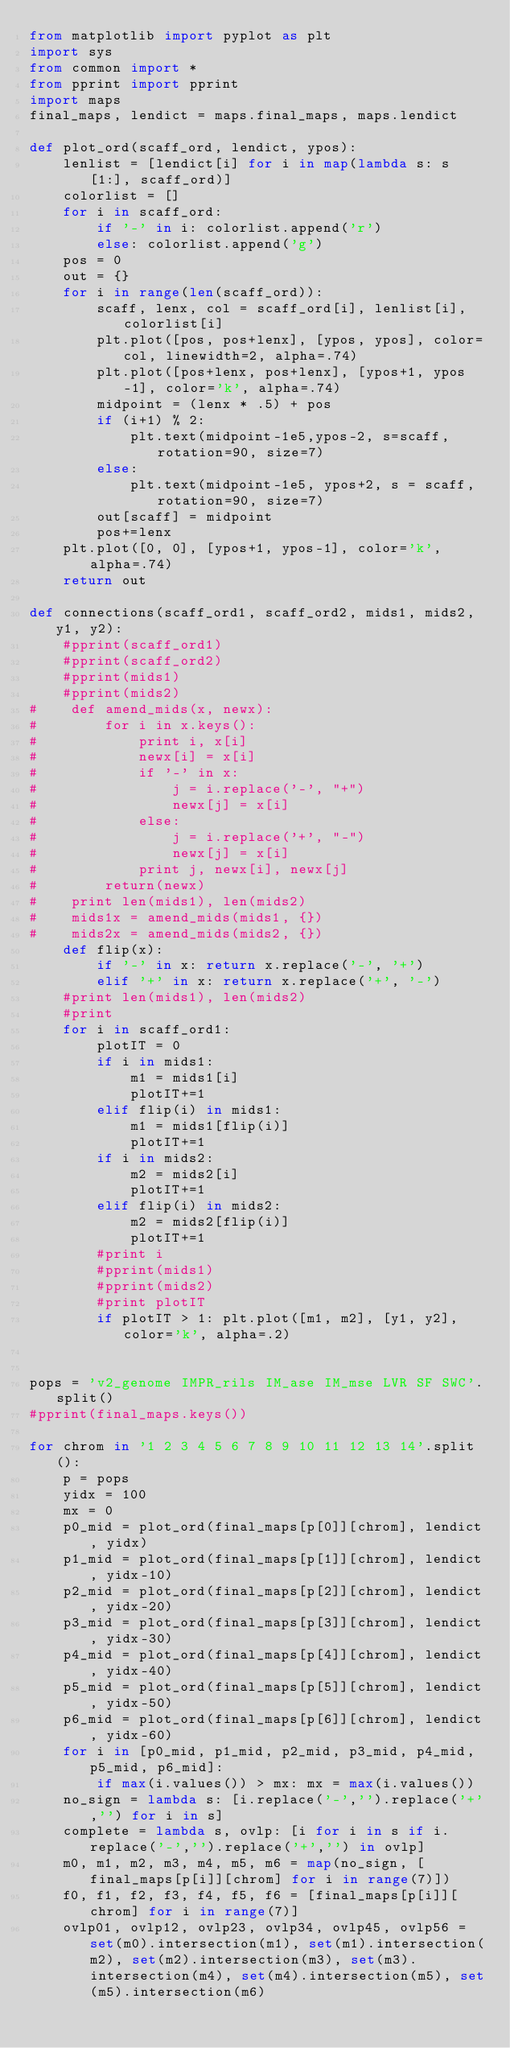Convert code to text. <code><loc_0><loc_0><loc_500><loc_500><_Python_>from matplotlib import pyplot as plt
import sys
from common import *
from pprint import pprint
import maps
final_maps, lendict = maps.final_maps, maps.lendict

def plot_ord(scaff_ord, lendict, ypos):
    lenlist = [lendict[i] for i in map(lambda s: s[1:], scaff_ord)]
    colorlist = []
    for i in scaff_ord:
        if '-' in i: colorlist.append('r')
        else: colorlist.append('g')
    pos = 0
    out = {}
    for i in range(len(scaff_ord)):
        scaff, lenx, col = scaff_ord[i], lenlist[i], colorlist[i]
        plt.plot([pos, pos+lenx], [ypos, ypos], color=col, linewidth=2, alpha=.74)
        plt.plot([pos+lenx, pos+lenx], [ypos+1, ypos-1], color='k', alpha=.74)
        midpoint = (lenx * .5) + pos
        if (i+1) % 2:
            plt.text(midpoint-1e5,ypos-2, s=scaff, rotation=90, size=7)
        else:
            plt.text(midpoint-1e5, ypos+2, s = scaff, rotation=90, size=7)
        out[scaff] = midpoint
        pos+=lenx
    plt.plot([0, 0], [ypos+1, ypos-1], color='k', alpha=.74)
    return out

def connections(scaff_ord1, scaff_ord2, mids1, mids2, y1, y2):
    #pprint(scaff_ord1)
    #pprint(scaff_ord2)
    #pprint(mids1)
    #pprint(mids2)
#    def amend_mids(x, newx):
#        for i in x.keys():
#            print i, x[i]
#            newx[i] = x[i]
#            if '-' in x:
#                j = i.replace('-', "+")
#                newx[j] = x[i]
#            else:
#                j = i.replace('+', "-")
#                newx[j] = x[i]
#            print j, newx[i], newx[j]
#        return(newx)
#    print len(mids1), len(mids2)
#    mids1x = amend_mids(mids1, {})
#    mids2x = amend_mids(mids2, {})
    def flip(x):
        if '-' in x: return x.replace('-', '+')
        elif '+' in x: return x.replace('+', '-')
    #print len(mids1), len(mids2)
    #print 
    for i in scaff_ord1:
        plotIT = 0
        if i in mids1:
            m1 = mids1[i]
            plotIT+=1
        elif flip(i) in mids1:
            m1 = mids1[flip(i)]
            plotIT+=1
        if i in mids2:
            m2 = mids2[i]
            plotIT+=1
        elif flip(i) in mids2:
            m2 = mids2[flip(i)]
            plotIT+=1
        #print i
        #pprint(mids1)
        #pprint(mids2)
        #print plotIT
        if plotIT > 1: plt.plot([m1, m2], [y1, y2], color='k', alpha=.2)
 
 
pops = 'v2_genome IMPR_rils IM_ase IM_mse LVR SF SWC'.split()   
#pprint(final_maps.keys())

for chrom in '1 2 3 4 5 6 7 8 9 10 11 12 13 14'.split():
    p = pops
    yidx = 100
    mx = 0
    p0_mid = plot_ord(final_maps[p[0]][chrom], lendict, yidx)
    p1_mid = plot_ord(final_maps[p[1]][chrom], lendict, yidx-10)
    p2_mid = plot_ord(final_maps[p[2]][chrom], lendict, yidx-20)
    p3_mid = plot_ord(final_maps[p[3]][chrom], lendict, yidx-30)
    p4_mid = plot_ord(final_maps[p[4]][chrom], lendict, yidx-40)
    p5_mid = plot_ord(final_maps[p[5]][chrom], lendict, yidx-50)
    p6_mid = plot_ord(final_maps[p[6]][chrom], lendict, yidx-60)
    for i in [p0_mid, p1_mid, p2_mid, p3_mid, p4_mid, p5_mid, p6_mid]:
        if max(i.values()) > mx: mx = max(i.values())
    no_sign = lambda s: [i.replace('-','').replace('+','') for i in s]
    complete = lambda s, ovlp: [i for i in s if i.replace('-','').replace('+','') in ovlp] 
    m0, m1, m2, m3, m4, m5, m6 = map(no_sign, [final_maps[p[i]][chrom] for i in range(7)])
    f0, f1, f2, f3, f4, f5, f6 = [final_maps[p[i]][chrom] for i in range(7)]
    ovlp01, ovlp12, ovlp23, ovlp34, ovlp45, ovlp56 = set(m0).intersection(m1), set(m1).intersection(m2), set(m2).intersection(m3), set(m3).intersection(m4), set(m4).intersection(m5), set(m5).intersection(m6)</code> 